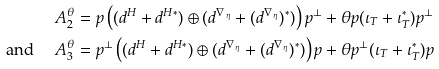Convert formula to latex. <formula><loc_0><loc_0><loc_500><loc_500>A _ { 2 } ^ { \theta } & = p \left ( ( d ^ { H } + d ^ { H * } ) \oplus ( d ^ { \nabla _ { \, \eta } } + ( d ^ { \nabla _ { \, \eta } } ) ^ { * } ) \right ) p ^ { \perp } + \theta p ( \iota _ { T } + \iota _ { T } ^ { * } ) p ^ { \perp } \\ { \text {and } } \quad A _ { 3 } ^ { \theta } & = p ^ { \perp } \left ( ( d ^ { H } + d ^ { H * } ) \oplus ( d ^ { \nabla _ { \, \eta } } + ( d ^ { \nabla _ { \, \eta } } ) ^ { * } ) \right ) p + \theta p ^ { \perp } ( \iota _ { T } + \iota _ { T } ^ { * } ) p</formula> 